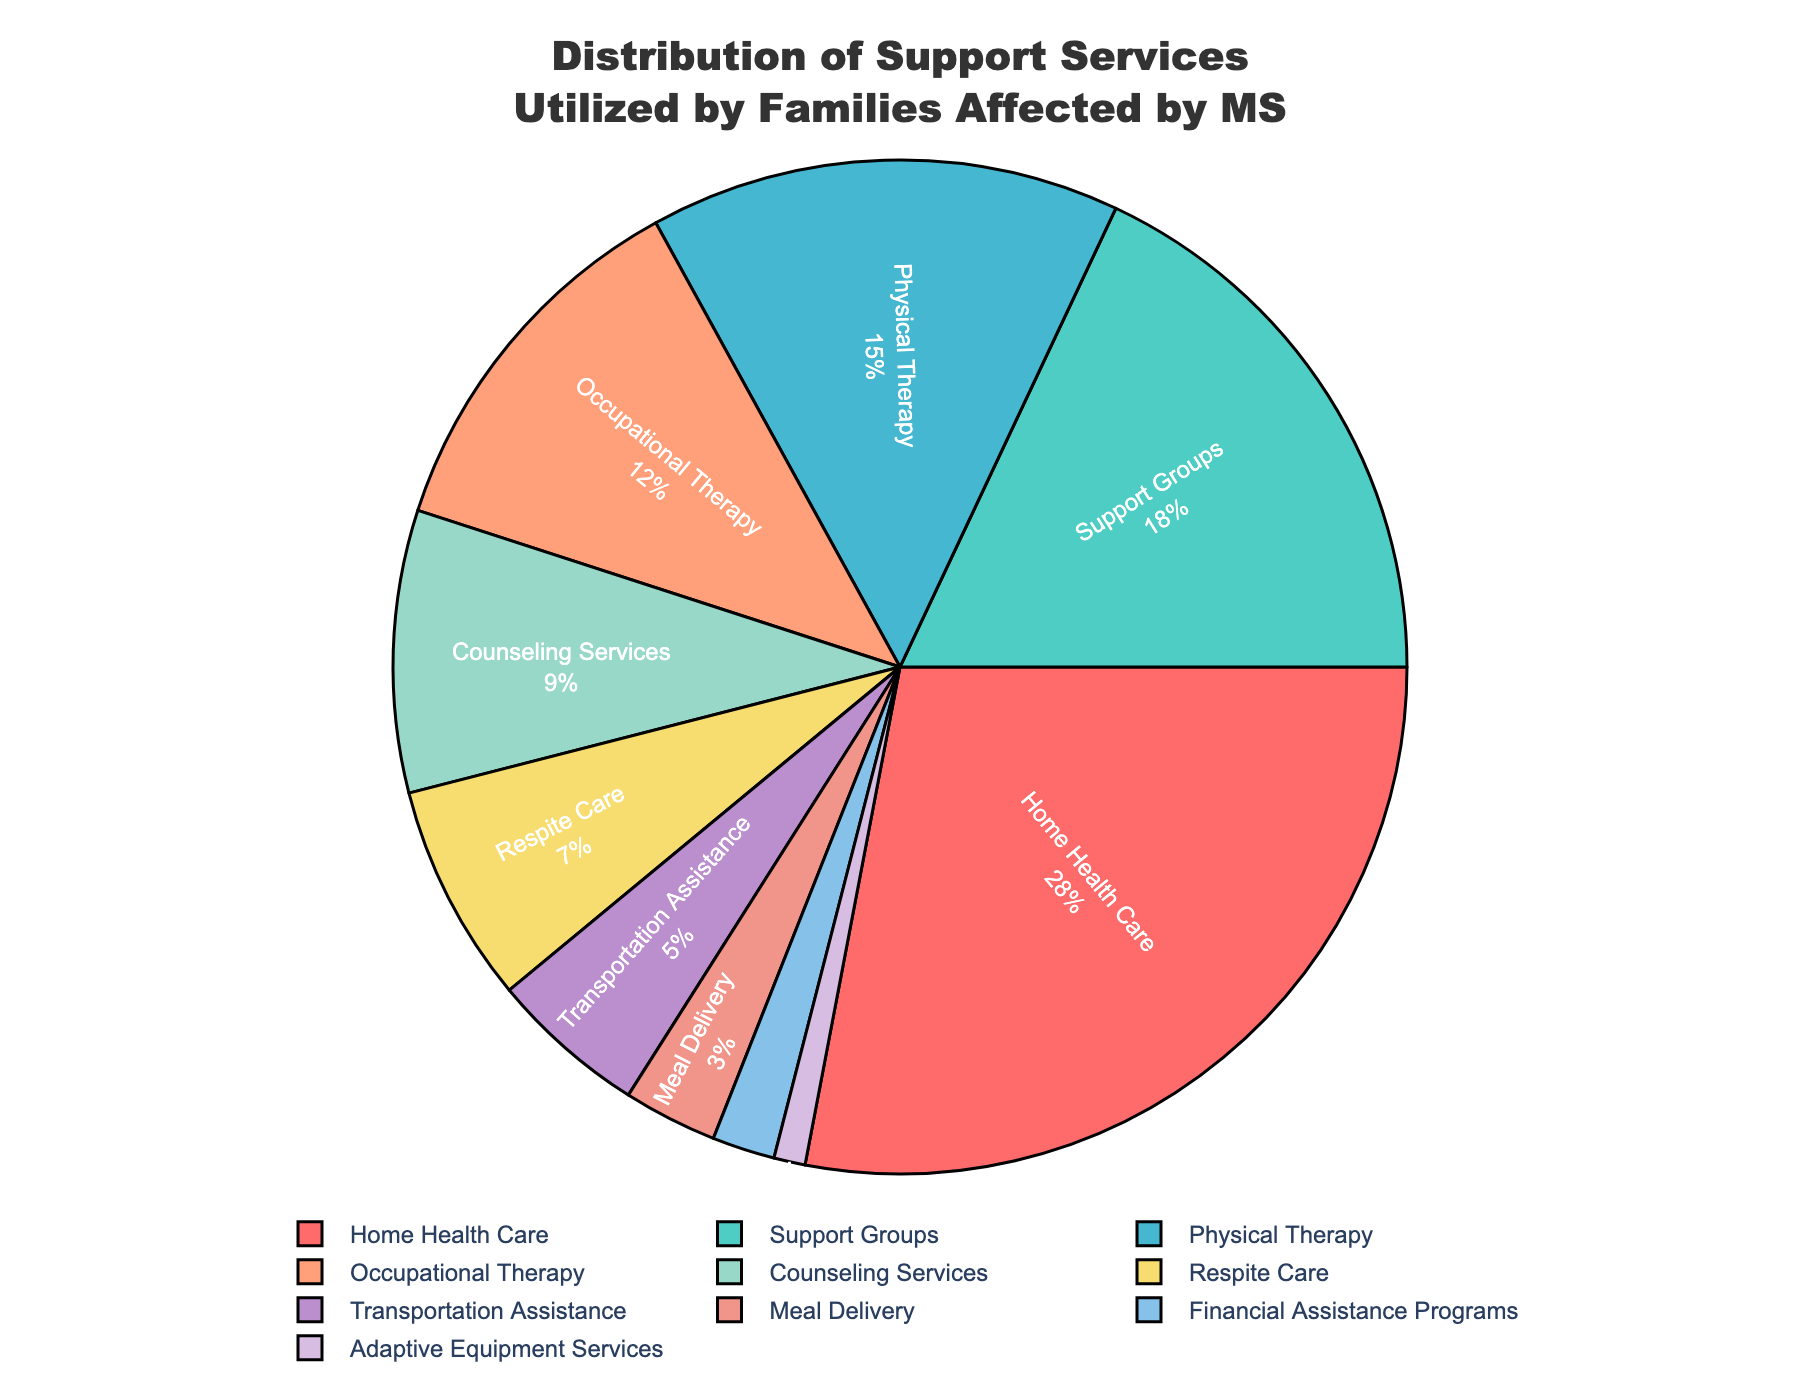What percentage of families use Home Health Care services? Home Health Care is shown with the highest percentage segment in the pie chart. By checking the label near the Home Health Care section of the pie chart, we can see the percentage.
Answer: 28% What is the combined percentage of families utilizing Physical Therapy and Occupational Therapy services? To find the combined percentage of Physical Therapy and Occupational Therapy, add the individual percentages from the pie chart: Physical Therapy (15%) + Occupational Therapy (12%) = 27%.
Answer: 27% Which service is utilized less, Respite Care or Transportation Assistance? By comparing the pie chart segments and their labels, we find that Transportation Assistance has a smaller percentage (5%) compared to Respite Care (7%).
Answer: Transportation Assistance What is the most commonly utilized support service by families affected by MS, and what color represents it on the chart? The pie chart shows Home Health Care as the largest segment with the highest percentage (28%). The color representing Home Health Care on the chart is red.
Answer: Home Health Care, red Is the percentage of families using Support Groups higher or lower than those using Counseling Services? By how much? Referring to the pie chart, Support Groups have a percentage of 18%, while Counseling Services have 9%. The difference is 18% - 9% = 9%.
Answer: Higher, by 9% What is the total percentage of families utilizing financial-related support services, namely Financial Assistance Programs and Meal Delivery services? Adding the percentages of Financial Assistance Programs (2%) and Meal Delivery services (3%) from the pie chart gives us a total combined percentage: 2% + 3% = 5%.
Answer: 5% What service has the smallest utilization rate, and what is its percentage? Adaptive Equipment Services is the smallest segment in the pie chart with the percentage given as 1%.
Answer: Adaptive Equipment Services, 1% Which two services have the next highest utilization rates after Home Health Care and Support Groups? By analyzing the pie chart segments in descending order, after Home Health Care (28%) and Support Groups (18%), the next highest services are Physical Therapy (15%) and Occupational Therapy (12%).
Answer: Physical Therapy and Occupational Therapy 